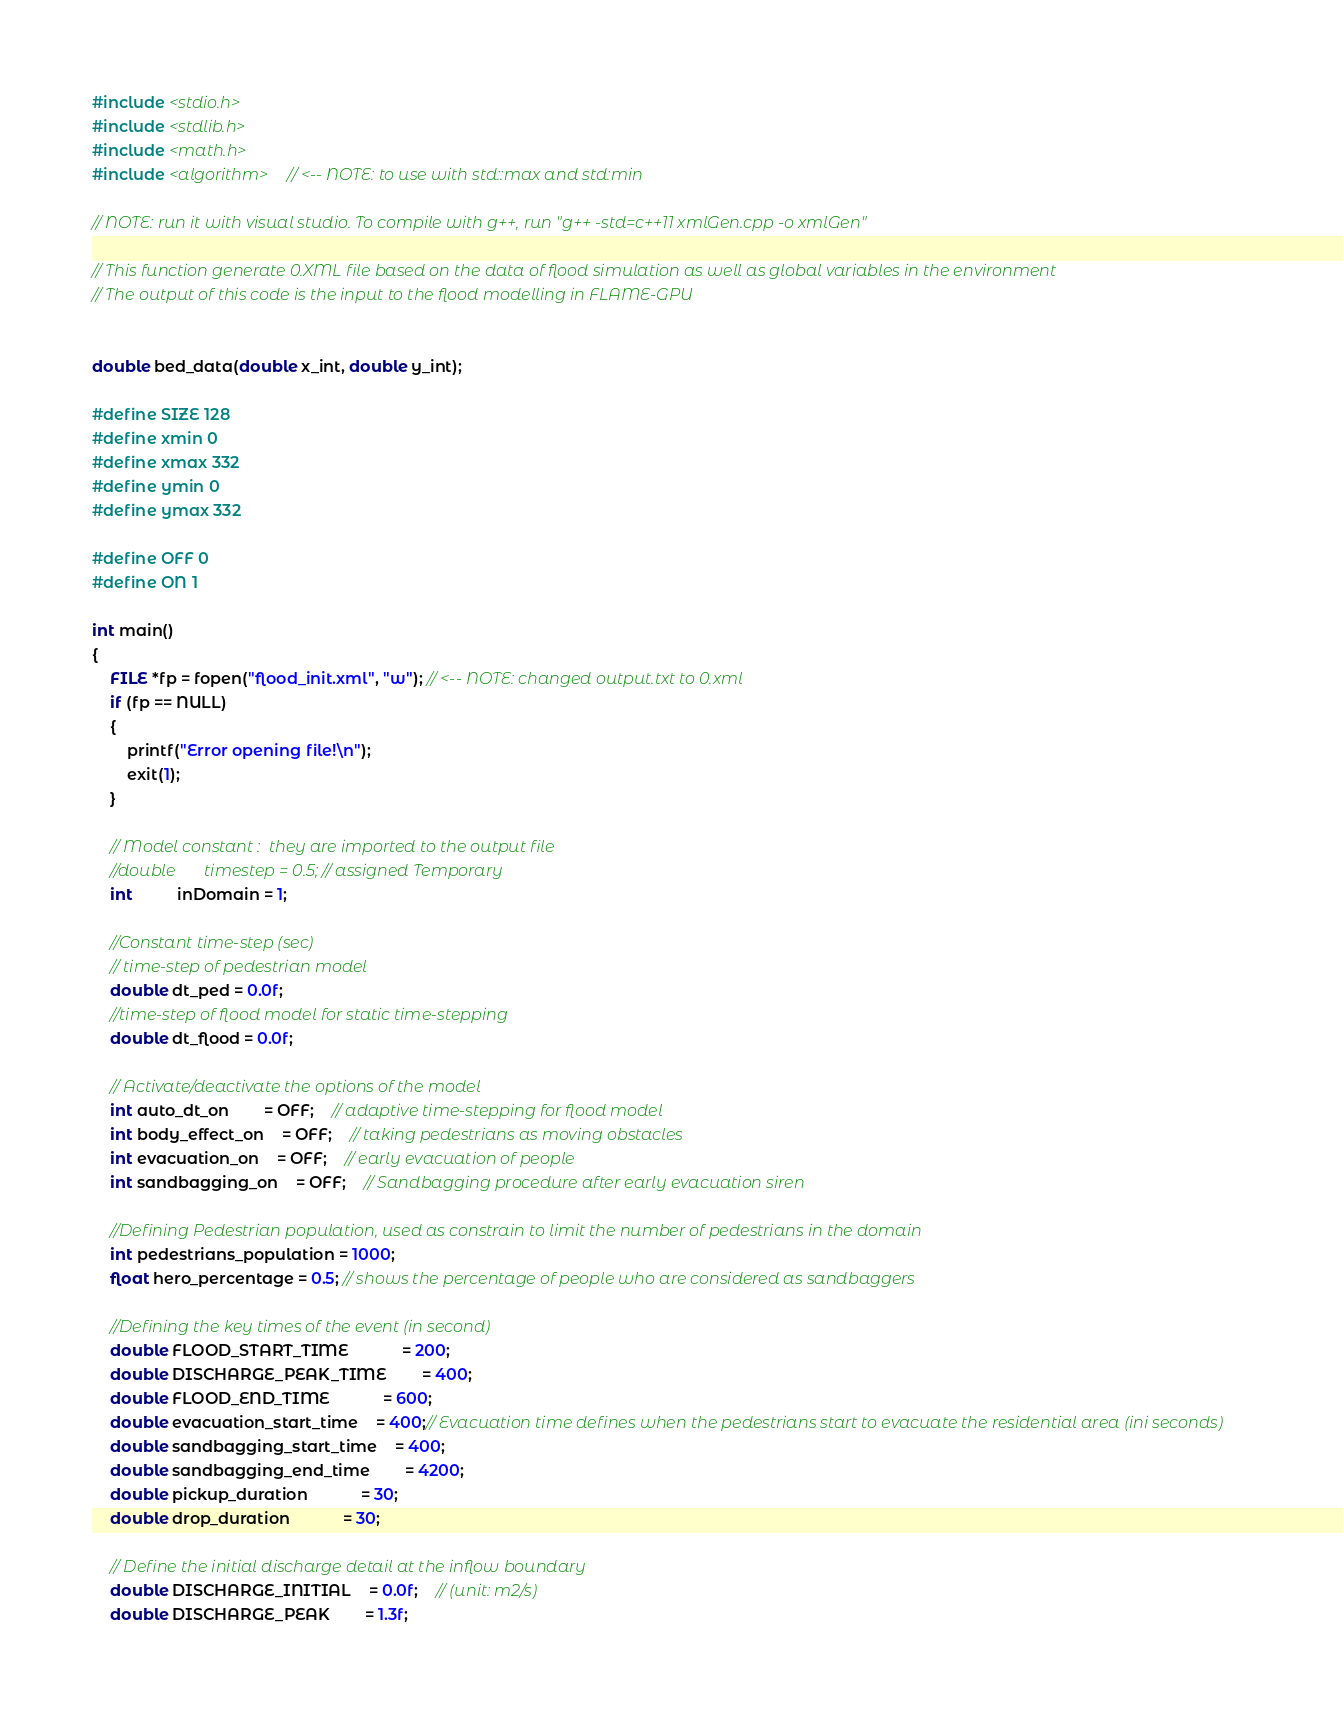<code> <loc_0><loc_0><loc_500><loc_500><_C++_>#include <stdio.h>
#include <stdlib.h>
#include <math.h>
#include <algorithm>    // <-- NOTE: to use with std::max and std:min

// NOTE: run it with visual studio. To compile with g++, run "g++ -std=c++11 xmlGen.cpp -o xmlGen"

// This function generate 0.XML file based on the data of flood simulation as well as global variables in the environment
// The output of this code is the input to the flood modelling in FLAME-GPU


double bed_data(double x_int, double y_int);

#define SIZE 128 
#define xmin 0
#define xmax 332
#define ymin 0
#define ymax 332

#define OFF 0
#define ON 1

int main()
{
	FILE *fp = fopen("flood_init.xml", "w"); // <-- NOTE: changed output.txt to 0.xml
	if (fp == NULL)
	{
		printf("Error opening file!\n");
		exit(1);
	}

	// Model constant :  they are imported to the output file          
	//double       timestep = 0.5; // assigned Temporary 
	int          inDomain = 1;

	//Constant time-step (sec)
	// time-step of pedestrian model 
	double dt_ped = 0.0f;
	//time-step of flood model for static time-stepping
	double dt_flood = 0.0f; 

	// Activate/deactivate the options of the model
	int auto_dt_on		= OFF;	// adaptive time-stepping for flood model
	int body_effect_on	= OFF;	// taking pedestrians as moving obstacles
	int evacuation_on	= OFF;	// early evacuation of people
	int sandbagging_on	= OFF;	// Sandbagging procedure after early evacuation siren

	//Defining Pedestrian population, used as constrain to limit the number of pedestrians in the domain
	int pedestrians_population = 1000; 
	float hero_percentage = 0.5; // shows the percentage of people who are considered as sandbaggers

	//Defining the key times of the event (in second)
	double FLOOD_START_TIME			= 200;
	double DISCHARGE_PEAK_TIME		= 400;
	double FLOOD_END_TIME			= 600;
	double evacuation_start_time	= 400;// Evacuation time defines when the pedestrians start to evacuate the residential area (ini seconds)
	double sandbagging_start_time	= 400;
	double sandbagging_end_time		= 4200;
	double pickup_duration			= 30;
	double drop_duration			= 30;

	// Define the initial discharge detail at the inflow boundary
	double DISCHARGE_INITIAL	= 0.0f;	// (unit: m2/s)
	double DISCHARGE_PEAK		= 1.3f;</code> 